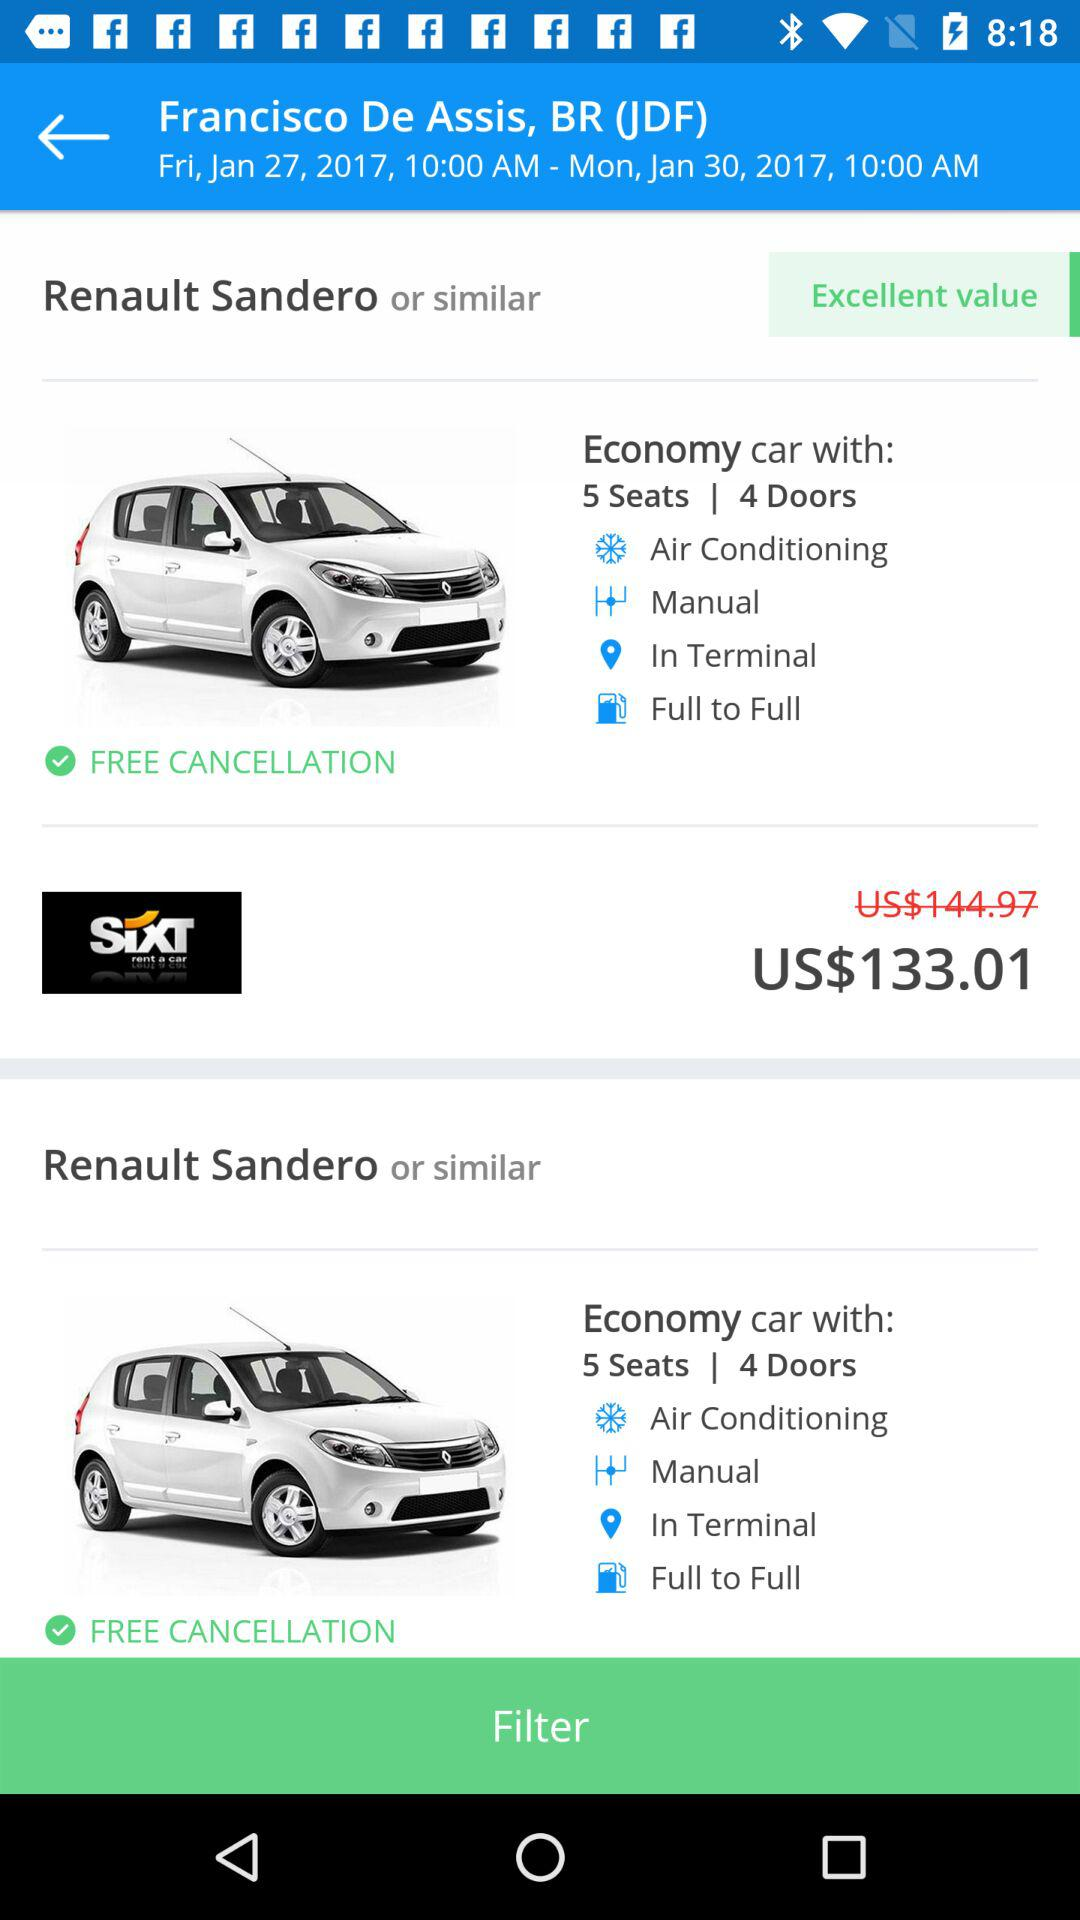Which date and time range are selected? The selected date and time range are Friday, January 27, 2017, 10:00 a.m. to Monday, January 30, 2017, 10:00 a.m. 